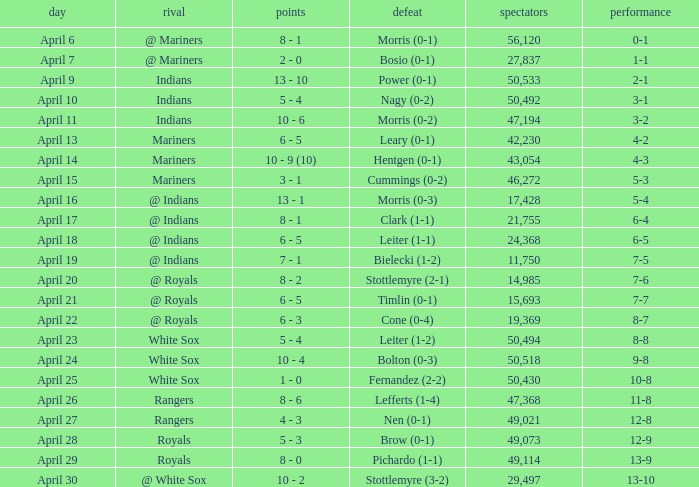What scored is recorded on April 24? 10 - 4. 